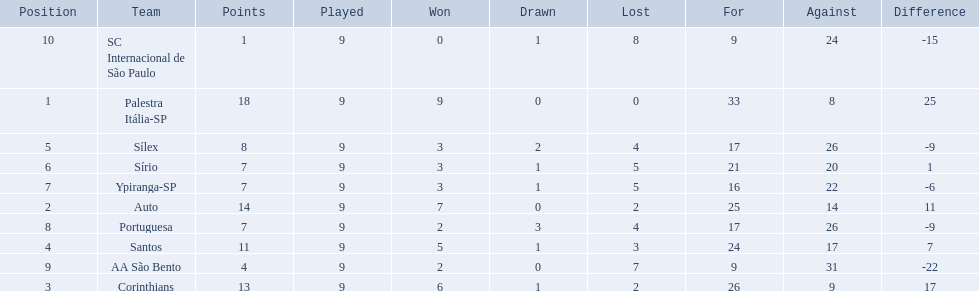How many teams played football in brazil during the year 1926? Palestra Itália-SP, Auto, Corinthians, Santos, Sílex, Sírio, Ypiranga-SP, Portuguesa, AA São Bento, SC Internacional de São Paulo. What was the highest number of games won during the 1926 season? 9. Which team was in the top spot with 9 wins for the 1926 season? Palestra Itália-SP. 